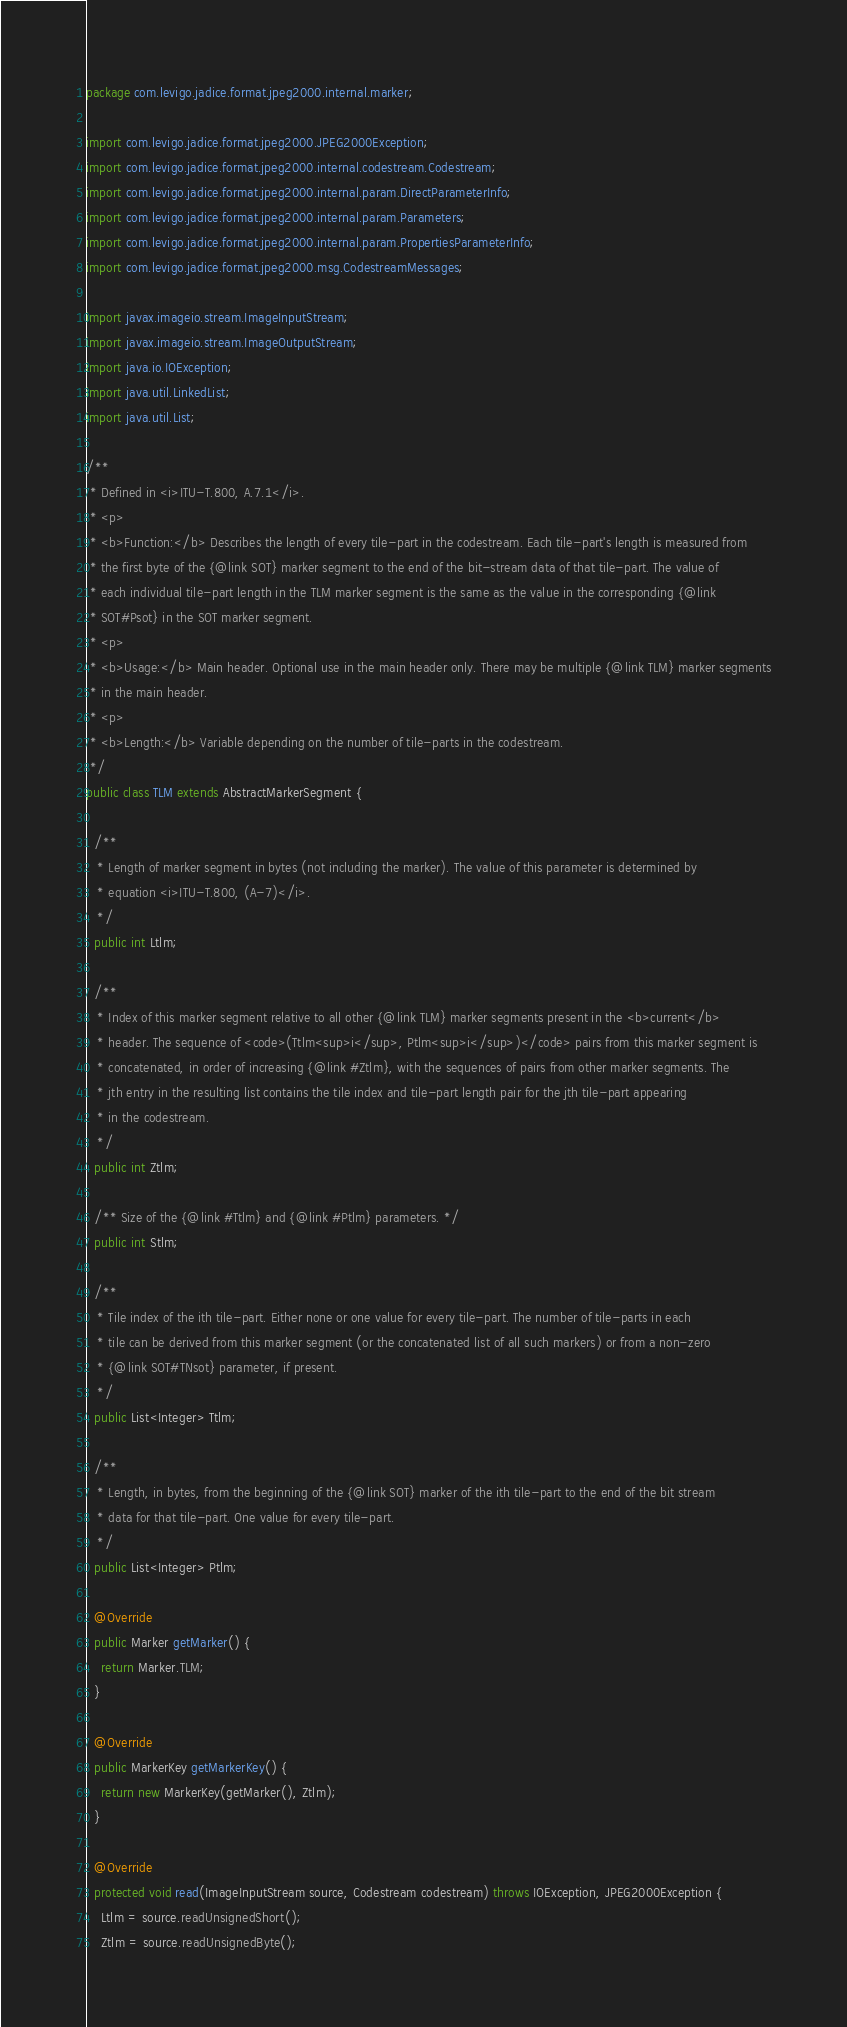Convert code to text. <code><loc_0><loc_0><loc_500><loc_500><_Java_>package com.levigo.jadice.format.jpeg2000.internal.marker;

import com.levigo.jadice.format.jpeg2000.JPEG2000Exception;
import com.levigo.jadice.format.jpeg2000.internal.codestream.Codestream;
import com.levigo.jadice.format.jpeg2000.internal.param.DirectParameterInfo;
import com.levigo.jadice.format.jpeg2000.internal.param.Parameters;
import com.levigo.jadice.format.jpeg2000.internal.param.PropertiesParameterInfo;
import com.levigo.jadice.format.jpeg2000.msg.CodestreamMessages;

import javax.imageio.stream.ImageInputStream;
import javax.imageio.stream.ImageOutputStream;
import java.io.IOException;
import java.util.LinkedList;
import java.util.List;

/**
 * Defined in <i>ITU-T.800, A.7.1</i>.
 * <p>
 * <b>Function:</b> Describes the length of every tile-part in the codestream. Each tile-part's length is measured from
 * the first byte of the {@link SOT} marker segment to the end of the bit-stream data of that tile-part. The value of
 * each individual tile-part length in the TLM marker segment is the same as the value in the corresponding {@link
 * SOT#Psot} in the SOT marker segment.
 * <p>
 * <b>Usage:</b> Main header. Optional use in the main header only. There may be multiple {@link TLM} marker segments
 * in the main header.
 * <p>
 * <b>Length:</b> Variable depending on the number of tile-parts in the codestream.
 */
public class TLM extends AbstractMarkerSegment {

  /**
   * Length of marker segment in bytes (not including the marker). The value of this parameter is determined by
   * equation <i>ITU-T.800, (A-7)</i>.
   */
  public int Ltlm;

  /**
   * Index of this marker segment relative to all other {@link TLM} marker segments present in the <b>current</b>
   * header. The sequence of <code>(Ttlm<sup>i</sup>, Ptlm<sup>i</sup>)</code> pairs from this marker segment is
   * concatenated, in order of increasing {@link #Ztlm}, with the sequences of pairs from other marker segments. The
   * jth entry in the resulting list contains the tile index and tile-part length pair for the jth tile-part appearing
   * in the codestream.
   */
  public int Ztlm;

  /** Size of the {@link #Ttlm} and {@link #Ptlm} parameters. */
  public int Stlm;

  /**
   * Tile index of the ith tile-part. Either none or one value for every tile-part. The number of tile-parts in each
   * tile can be derived from this marker segment (or the concatenated list of all such markers) or from a non-zero
   * {@link SOT#TNsot} parameter, if present.
   */
  public List<Integer> Ttlm;

  /**
   * Length, in bytes, from the beginning of the {@link SOT} marker of the ith tile-part to the end of the bit stream
   * data for that tile-part. One value for every tile-part.
   */
  public List<Integer> Ptlm;

  @Override
  public Marker getMarker() {
    return Marker.TLM;
  }

  @Override
  public MarkerKey getMarkerKey() {
    return new MarkerKey(getMarker(), Ztlm);
  }

  @Override
  protected void read(ImageInputStream source, Codestream codestream) throws IOException, JPEG2000Exception {
    Ltlm = source.readUnsignedShort();
    Ztlm = source.readUnsignedByte();</code> 